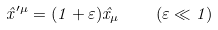Convert formula to latex. <formula><loc_0><loc_0><loc_500><loc_500>\hat { x } ^ { \prime \mu } = ( 1 + \varepsilon ) \hat { x } _ { \mu } \quad ( \varepsilon \ll 1 )</formula> 